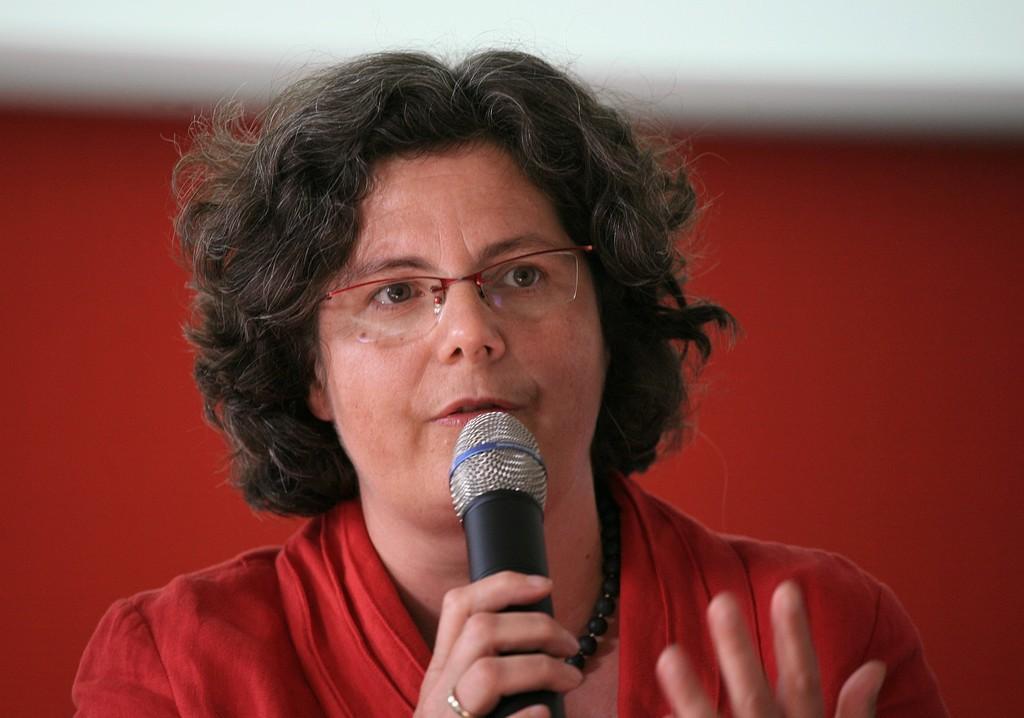Describe this image in one or two sentences. In this image I can see a woman is holding a mic, I can also see she is wearing a specs and red color top. 